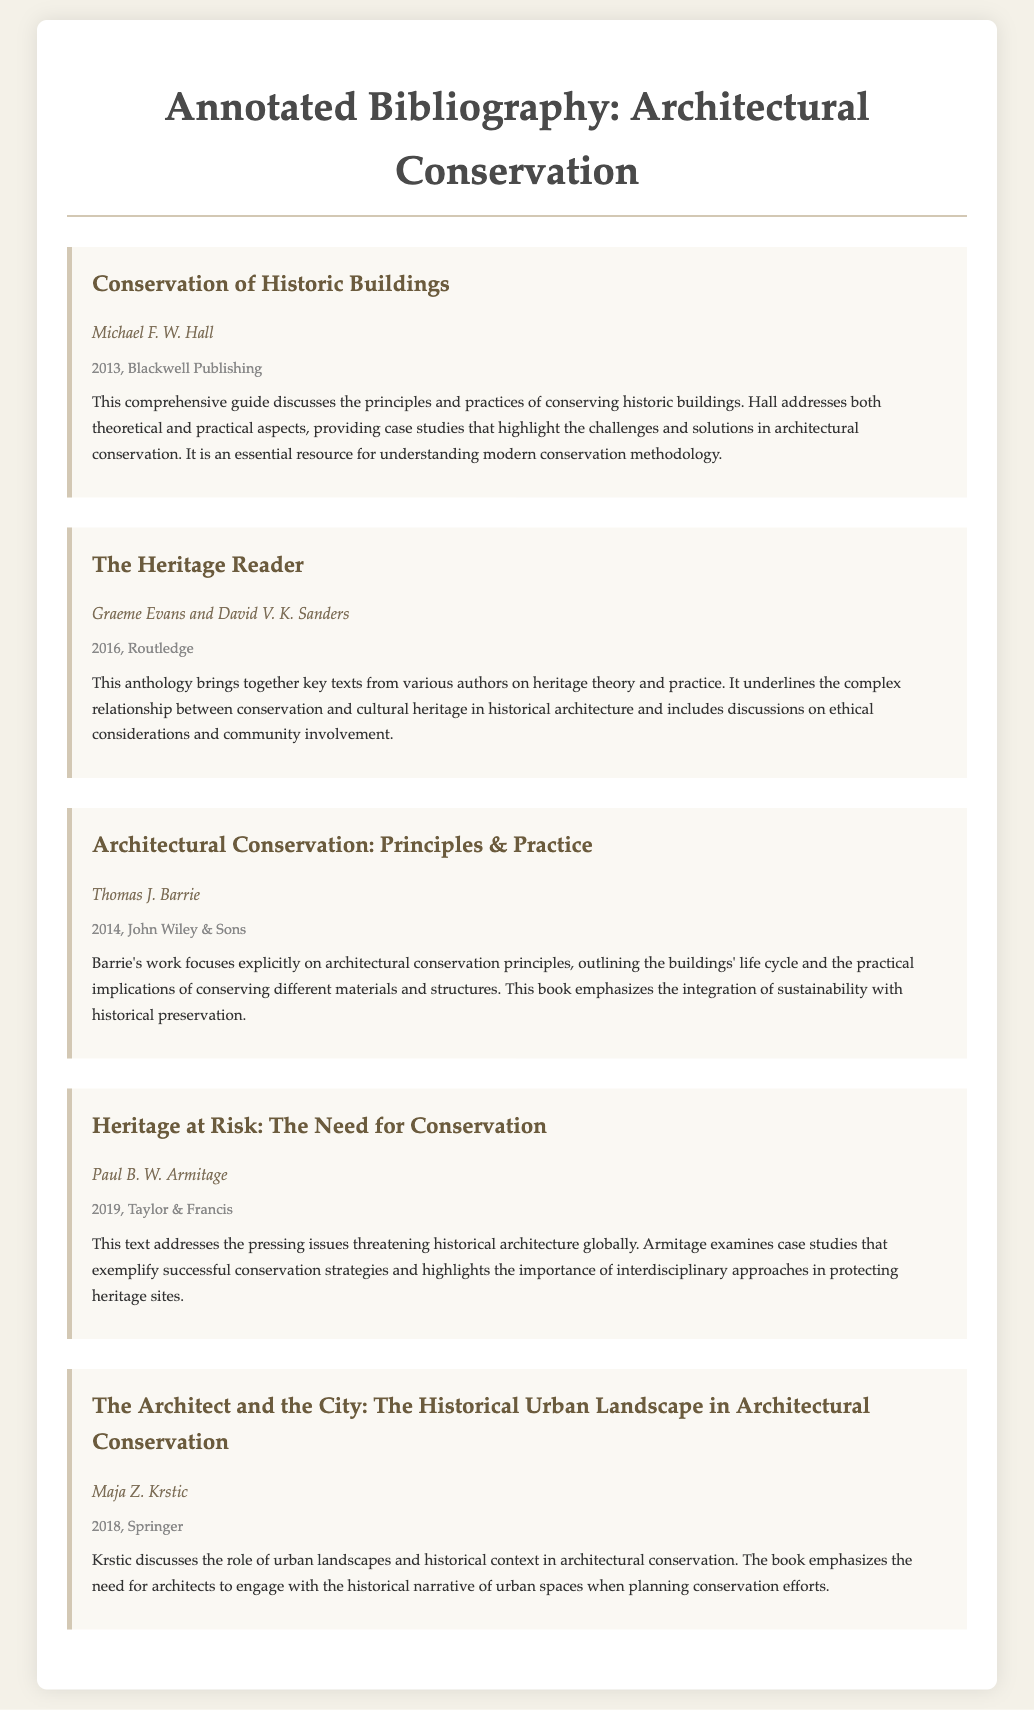What is the title of the first entry? The title is the name of the first bibliography item, which is located at the top of the bibliography section.
Answer: Conservation of Historic Buildings Who is the author of "Architectural Conservation: Principles & Practice"? The author's name can be found directly below the title of the corresponding bibliography item.
Answer: Thomas J. Barrie In what year was "Heritage at Risk: The Need for Conservation" published? The publication year is found in the citation information of the bibliography item.
Answer: 2019 Which publisher released "The Heritage Reader"? The publisher's name is included in the bibliographic details of the work.
Answer: Routledge What main theme does Maja Z. Krstic's book focus on? The theme can be inferred from the title and annotation of the bibliography item.
Answer: The historical urban landscape List one aspect that Paul B. W. Armitage emphasizes in his work. The aspect is derived from the annotation summarizing the key points of the book.
Answer: Interdisciplinary approaches Identify the type of publication format represented in this document. The document consists of a structured presentation of bibliographic information with annotations.
Answer: Annotated bibliography Which bibliography item discusses ethical considerations in conservation? The specific entry that focuses on ethical issues can be found within the annotations of the entries.
Answer: The Heritage Reader 